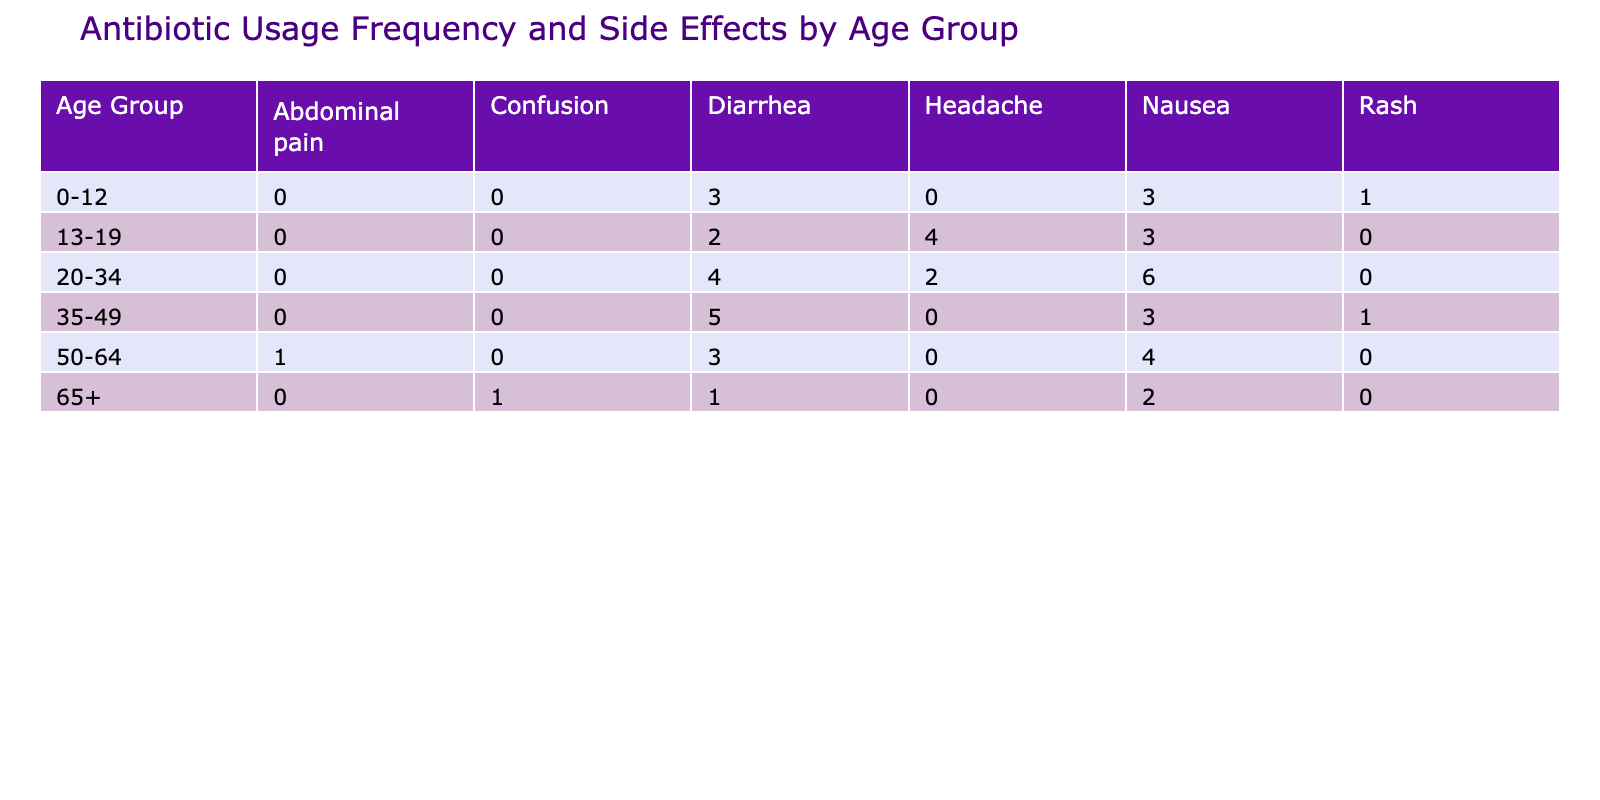What is the most common side effect reported for the 20-34 age group? For the age group 20-34, we look at the 'Common Side Effects' column and see the counts. Nausea is reported 6 times, which is higher than any other side effect in this group.
Answer: Nausea How many times is diarrhea reported across all age groups? We need to sum the frequency of diarrhea across all entries. In the table, diarrhea appears for the following age groups: 0-12 (3 + 1 = 4), 13-19 (2), 20-34 (4), 35-49 (5), 50-64 (3), and 65+ (1). Adding these gives us 4 + 2 + 4 + 5 + 3 + 1 = 19.
Answer: 19 Is nausea reported more frequently than diarrhea in the 35-49 age group? We check the frequencies in the 35-49 group specifically: Nausea is reported 3 times, while diarrhea is reported 5 times. Since 5 is greater than 3, nausea is not reported more frequently in this case.
Answer: No What is the average antibiotic usage frequency for the 50-64 age group? In the 50-64 age group, the reported frequencies are 4, 3, and 1. To find the average, we sum these frequencies: 4 + 3 + 1 = 8. Since there are three entries, we divide by 3: 8 / 3 = approximately 2.67.
Answer: 2.67 Which age group has the highest total frequency of antibiotic usage? To find out which age group has the highest total, we need to sum the frequencies for each group: 0-12 (3 + 3 + 1 = 7), 13-19 (4 + 3 + 2 = 9), 20-34 (6 + 4 + 2 = 12), 35-49 (5 + 3 + 1 = 9), 50-64 (4 + 3 + 1 = 8), 65+ (2 + 1 + 1 = 4). The highest sum is for the 20-34 age group with a total of 12.
Answer: 20-34 Is the frequency of side effects the same across all age groups? We have to look at the distribution of side effects across age groups. Summing the occurrences for every age group shows that there are different frequencies of side effects, so they are not the same across the groups.
Answer: No 